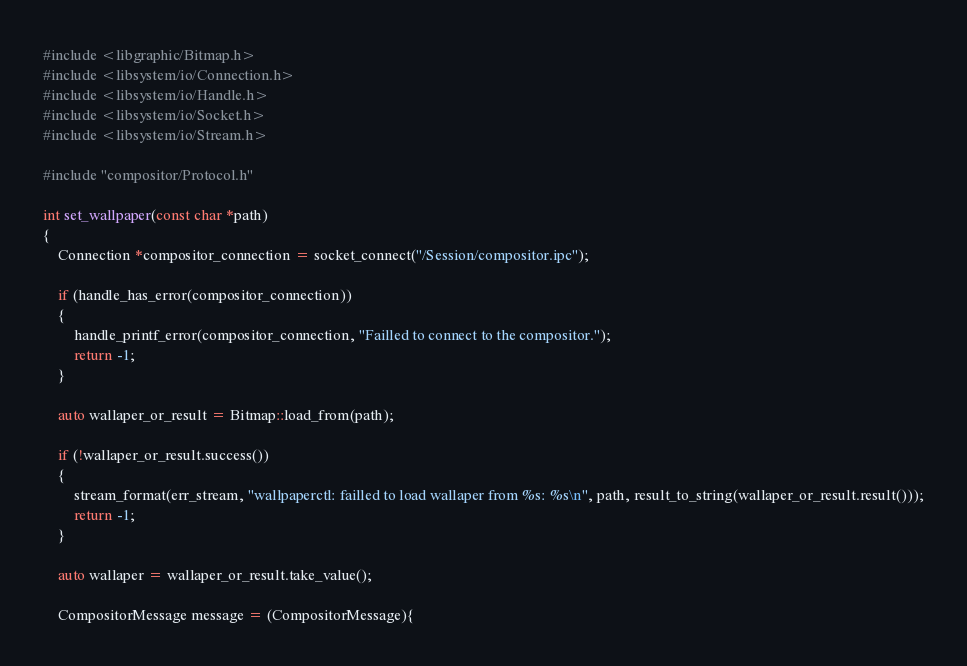<code> <loc_0><loc_0><loc_500><loc_500><_C++_>#include <libgraphic/Bitmap.h>
#include <libsystem/io/Connection.h>
#include <libsystem/io/Handle.h>
#include <libsystem/io/Socket.h>
#include <libsystem/io/Stream.h>

#include "compositor/Protocol.h"

int set_wallpaper(const char *path)
{
    Connection *compositor_connection = socket_connect("/Session/compositor.ipc");

    if (handle_has_error(compositor_connection))
    {
        handle_printf_error(compositor_connection, "Failled to connect to the compositor.");
        return -1;
    }

    auto wallaper_or_result = Bitmap::load_from(path);

    if (!wallaper_or_result.success())
    {
        stream_format(err_stream, "wallpaperctl: failled to load wallaper from %s: %s\n", path, result_to_string(wallaper_or_result.result()));
        return -1;
    }

    auto wallaper = wallaper_or_result.take_value();

    CompositorMessage message = (CompositorMessage){</code> 